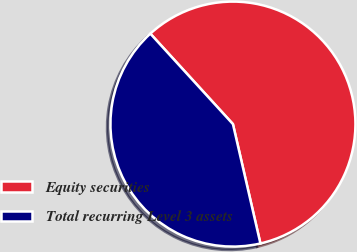Convert chart. <chart><loc_0><loc_0><loc_500><loc_500><pie_chart><fcel>Equity securities<fcel>Total recurring Level 3 assets<nl><fcel>58.18%<fcel>41.82%<nl></chart> 